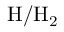<formula> <loc_0><loc_0><loc_500><loc_500>H / H _ { 2 }</formula> 